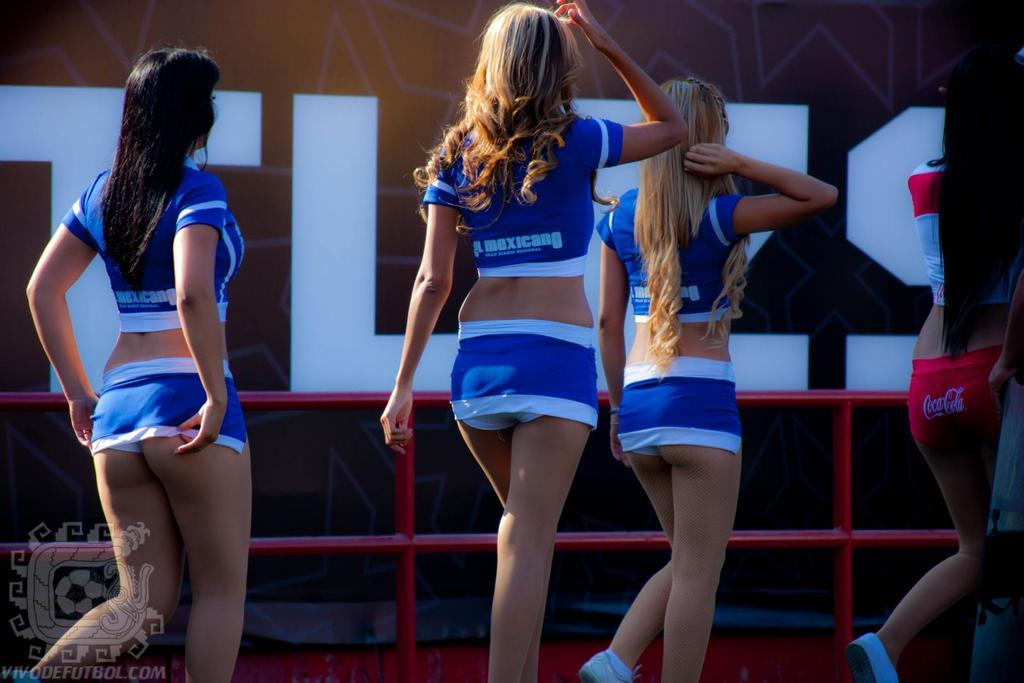How many people are in the image? There are four girls in the image. What are the girls doing in the image? The girls are walking. Where might the logo be located in the image? The logo is at the left bottom of the image. What can be seen in the background of the image? There is railing visible in the image. What type of trees can be seen in the image? There are no trees present in the image; it features four girls walking and a logo with railing in the background. 